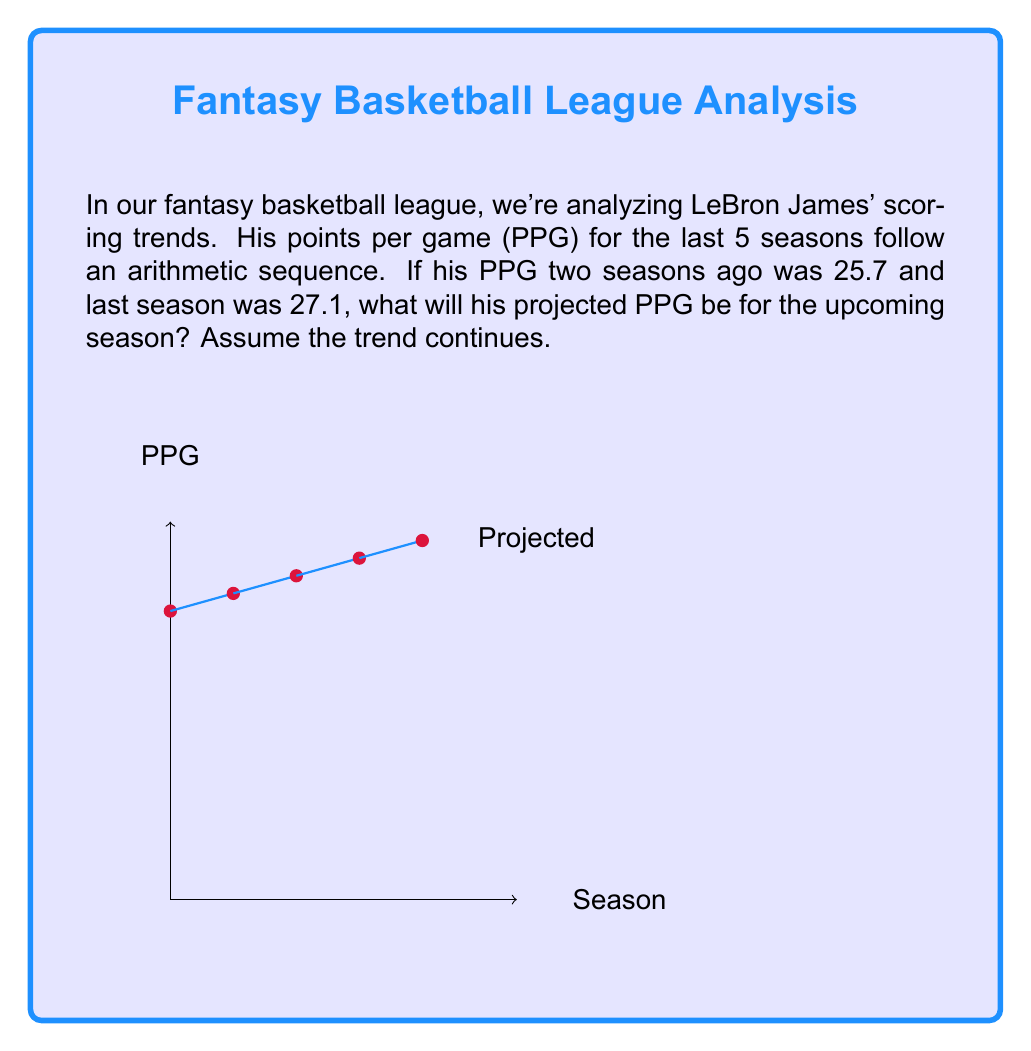Give your solution to this math problem. Let's approach this step-by-step:

1) In an arithmetic sequence, the difference between any two consecutive terms is constant. Let's call this common difference $d$.

2) We're given two consecutive terms:
   Two seasons ago: $a_n = 25.7$
   Last season: $a_{n+1} = 27.1$

3) We can find $d$ using the formula:
   $d = a_{n+1} - a_n = 27.1 - 25.7 = 1.4$

4) In an arithmetic sequence, each term is the sum of the previous term and the common difference:
   $a_{n+2} = a_{n+1} + d$

5) Therefore, the projected PPG for the upcoming season is:
   $a_{n+2} = 27.1 + 1.4 = 28.5$

This matches the trend shown in the graph, where we can see the projected point for the upcoming season at (4, 28.5).
Answer: 28.5 PPG 